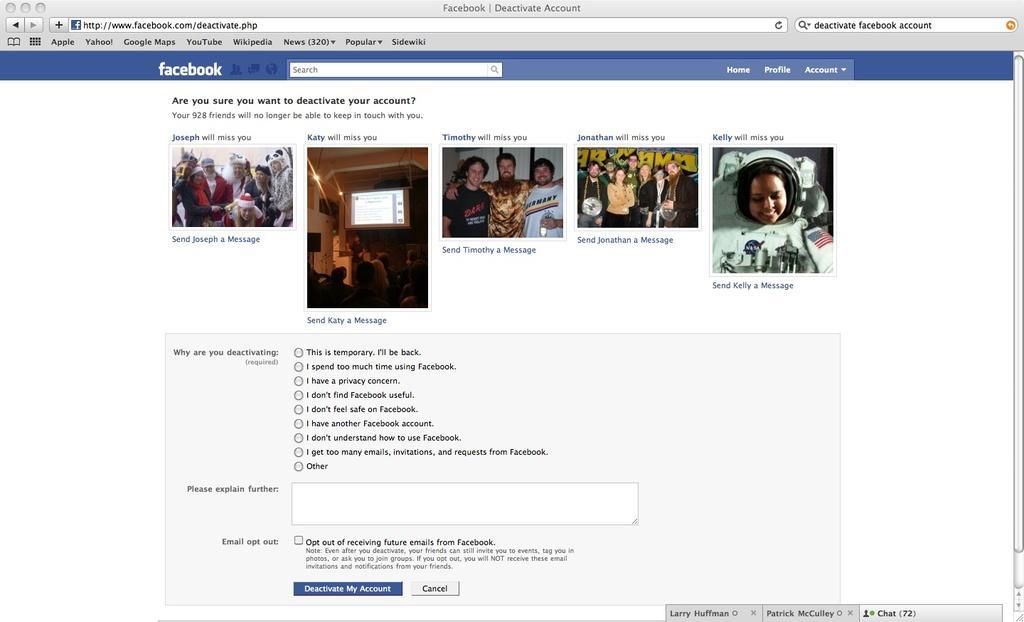Can you describe this image briefly? In the center of the image we can see a web page. On the web page, we can see a few people, some text and a few other objects. 